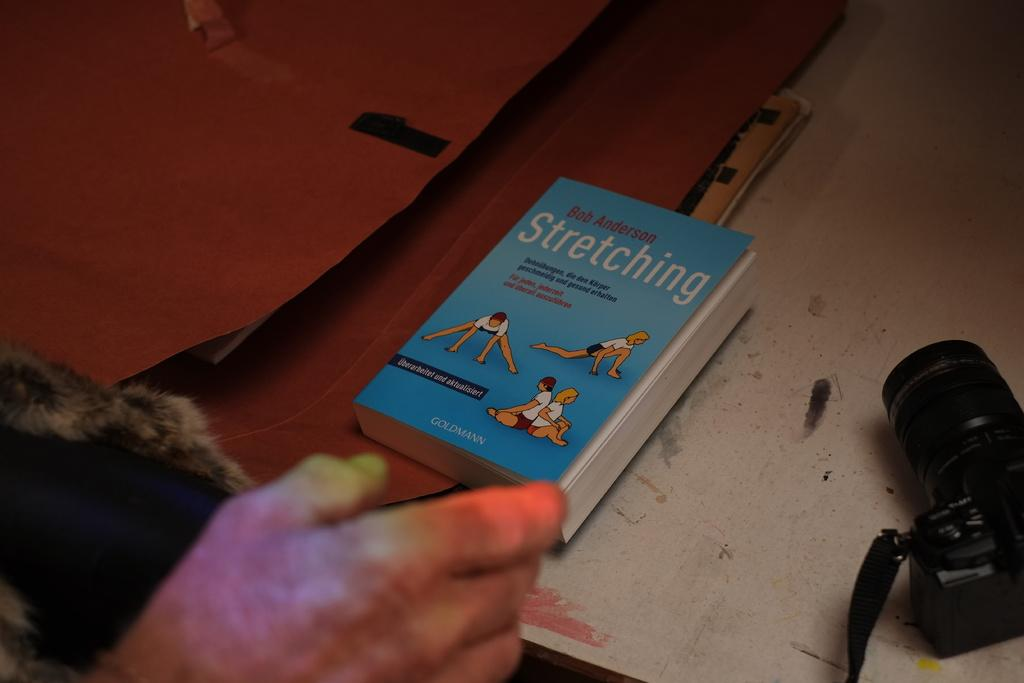<image>
Summarize the visual content of the image. a book on a table about stretching exercises 